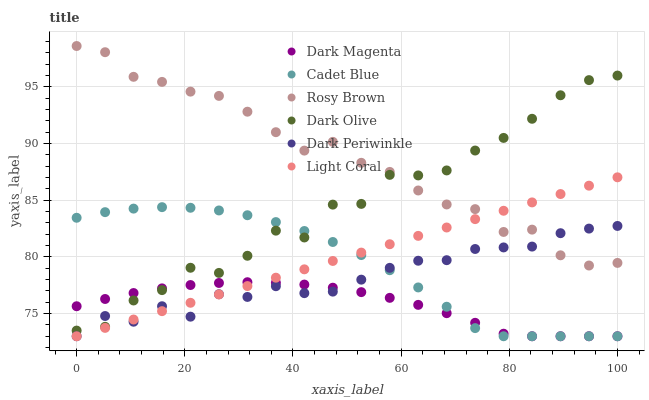Does Dark Magenta have the minimum area under the curve?
Answer yes or no. Yes. Does Rosy Brown have the maximum area under the curve?
Answer yes or no. Yes. Does Dark Olive have the minimum area under the curve?
Answer yes or no. No. Does Dark Olive have the maximum area under the curve?
Answer yes or no. No. Is Light Coral the smoothest?
Answer yes or no. Yes. Is Dark Olive the roughest?
Answer yes or no. Yes. Is Dark Magenta the smoothest?
Answer yes or no. No. Is Dark Magenta the roughest?
Answer yes or no. No. Does Dark Magenta have the lowest value?
Answer yes or no. Yes. Does Dark Olive have the lowest value?
Answer yes or no. No. Does Rosy Brown have the highest value?
Answer yes or no. Yes. Does Dark Olive have the highest value?
Answer yes or no. No. Is Cadet Blue less than Rosy Brown?
Answer yes or no. Yes. Is Rosy Brown greater than Cadet Blue?
Answer yes or no. Yes. Does Light Coral intersect Cadet Blue?
Answer yes or no. Yes. Is Light Coral less than Cadet Blue?
Answer yes or no. No. Is Light Coral greater than Cadet Blue?
Answer yes or no. No. Does Cadet Blue intersect Rosy Brown?
Answer yes or no. No. 